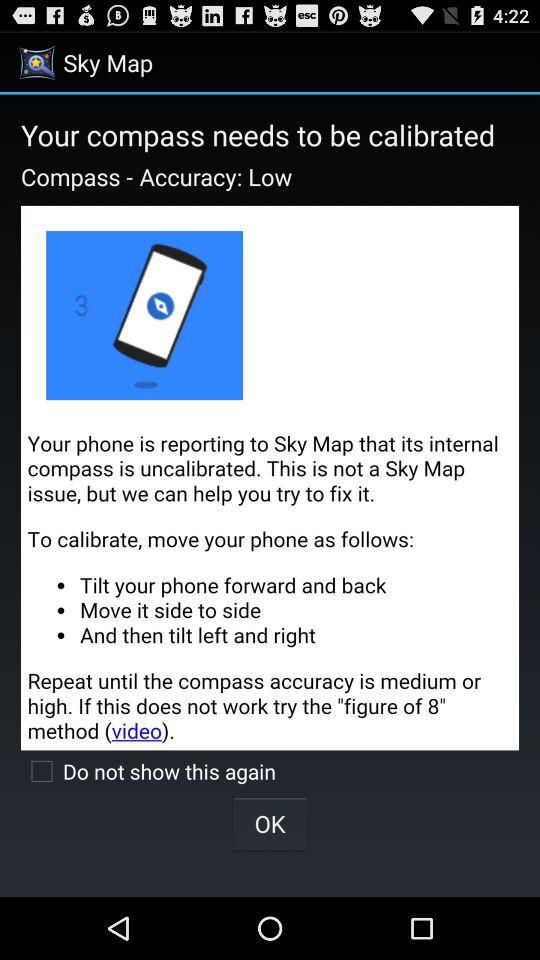How long is the video?
When the provided information is insufficient, respond with <no answer>. <no answer> 